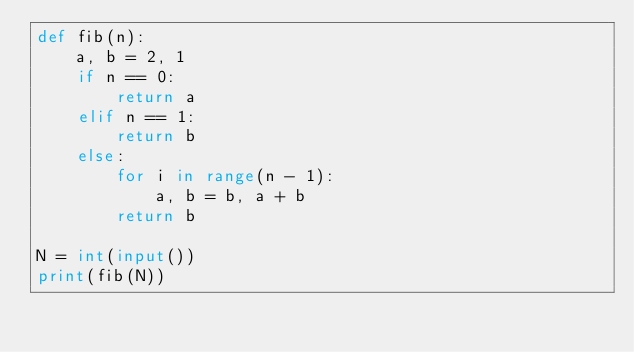<code> <loc_0><loc_0><loc_500><loc_500><_Python_>def fib(n):
    a, b = 2, 1
    if n == 0:
        return a
    elif n == 1:
        return b
    else:
        for i in range(n - 1):
            a, b = b, a + b
        return b

N = int(input())
print(fib(N))</code> 